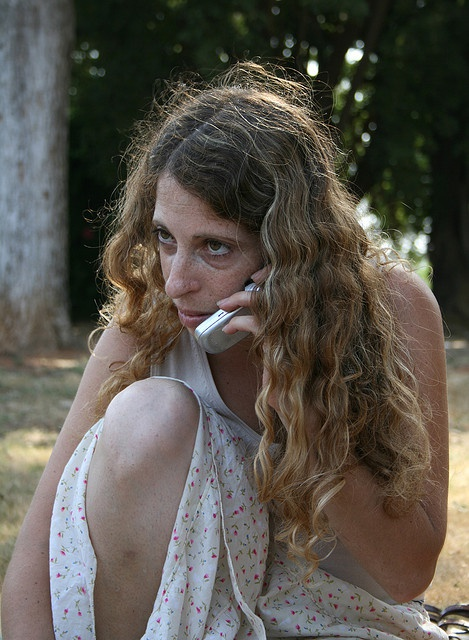Describe the objects in this image and their specific colors. I can see people in gray, black, darkgray, and maroon tones and cell phone in gray, white, and black tones in this image. 